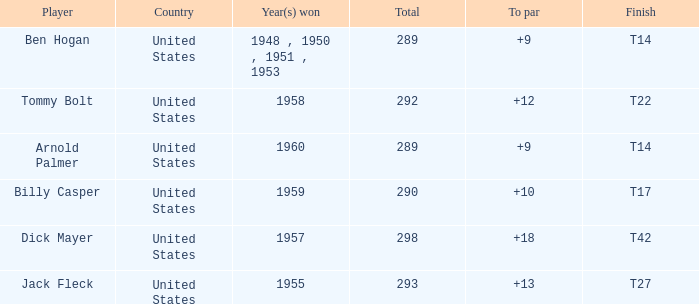What is Player, when Year(s) Won is 1955? Jack Fleck. 